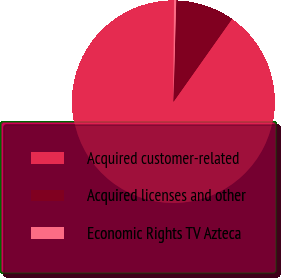<chart> <loc_0><loc_0><loc_500><loc_500><pie_chart><fcel>Acquired customer-related<fcel>Acquired licenses and other<fcel>Economic Rights TV Azteca<nl><fcel>90.3%<fcel>9.35%<fcel>0.35%<nl></chart> 